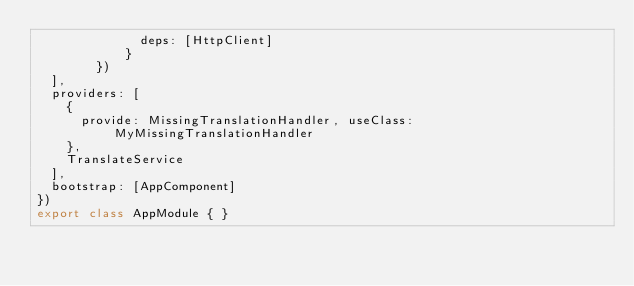<code> <loc_0><loc_0><loc_500><loc_500><_TypeScript_>			  deps: [HttpClient]
			}
		})
  ],
  providers: [ 
    { 
      provide: MissingTranslationHandler, useClass: MyMissingTranslationHandler
    }, 
    TranslateService
  ],
  bootstrap: [AppComponent]
})
export class AppModule { }
</code> 